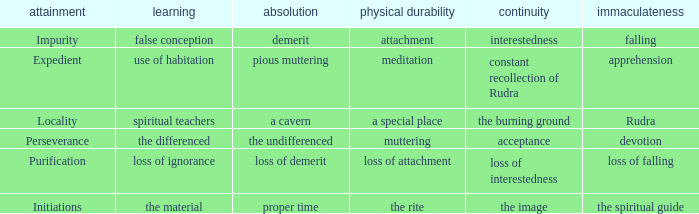 what's the permanence of the body where purity is apprehension Meditation. 